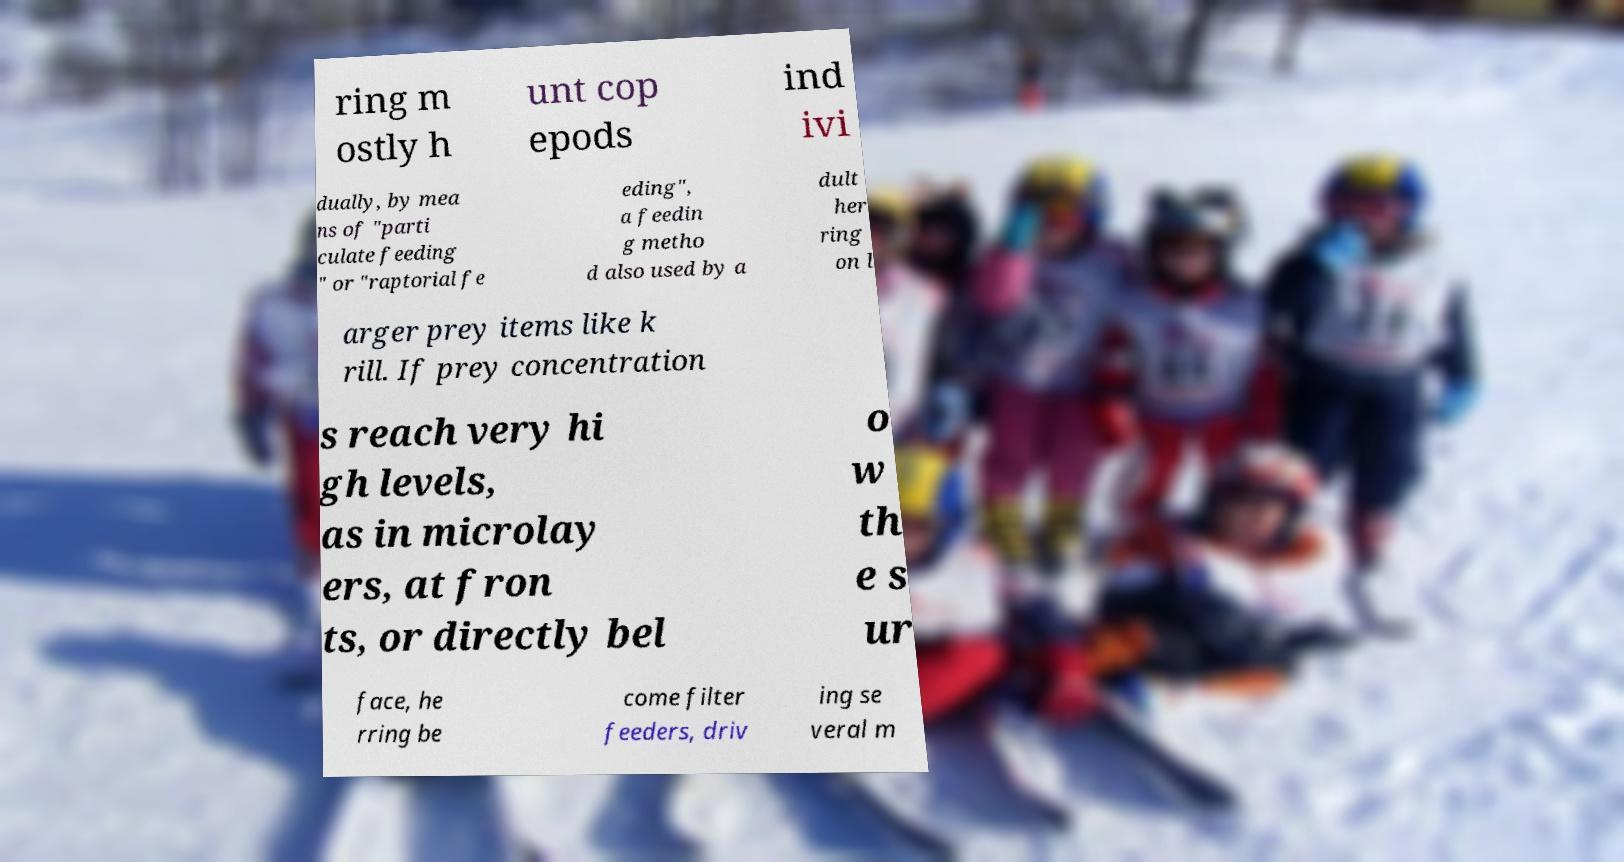For documentation purposes, I need the text within this image transcribed. Could you provide that? ring m ostly h unt cop epods ind ivi dually, by mea ns of "parti culate feeding " or "raptorial fe eding", a feedin g metho d also used by a dult her ring on l arger prey items like k rill. If prey concentration s reach very hi gh levels, as in microlay ers, at fron ts, or directly bel o w th e s ur face, he rring be come filter feeders, driv ing se veral m 